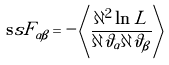<formula> <loc_0><loc_0><loc_500><loc_500>\mathbf s s F _ { \alpha \beta } = - \left \langle \frac { \partial ^ { 2 } \ln L } { \partial \vartheta _ { \alpha } \partial \vartheta _ { \beta } } \right \rangle</formula> 